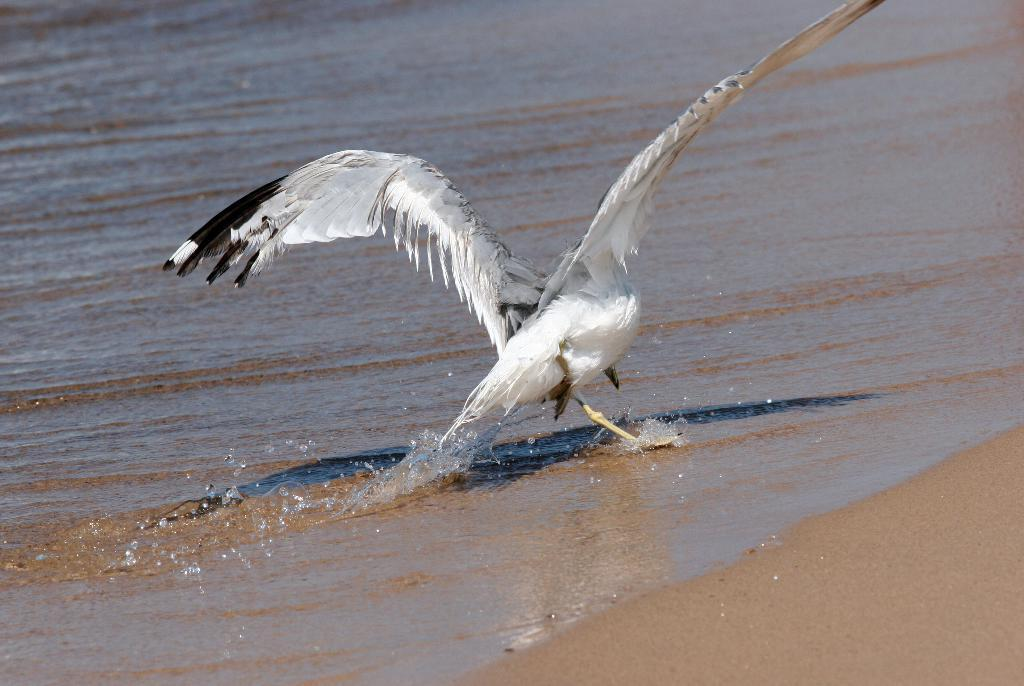What type of animal is in the image? There is a bird in the image. What colors can be seen on the bird? The bird is white and black in color. What type of terrain is visible to the right of the bird? There is sand visible to the right of the bird. What type of terrain is visible to the left of the bird? There is water visible to the left of the bird. What type of education is the boy receiving in the image? There is no boy present in the image, and therefore no education can be observed. 